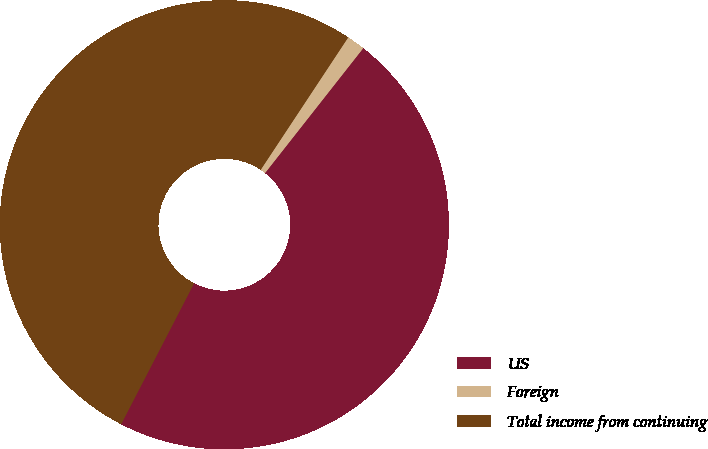Convert chart. <chart><loc_0><loc_0><loc_500><loc_500><pie_chart><fcel>US<fcel>Foreign<fcel>Total income from continuing<nl><fcel>47.0%<fcel>1.31%<fcel>51.7%<nl></chart> 